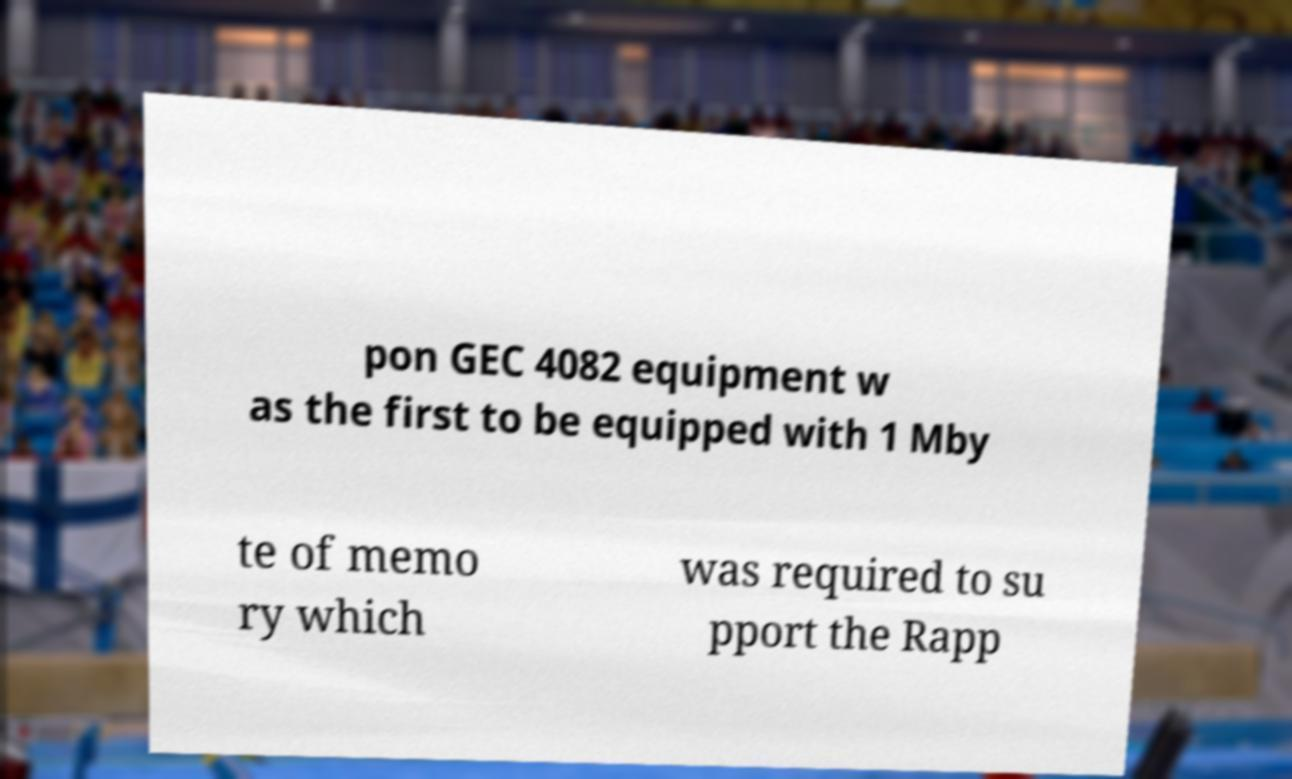Can you accurately transcribe the text from the provided image for me? pon GEC 4082 equipment w as the first to be equipped with 1 Mby te of memo ry which was required to su pport the Rapp 